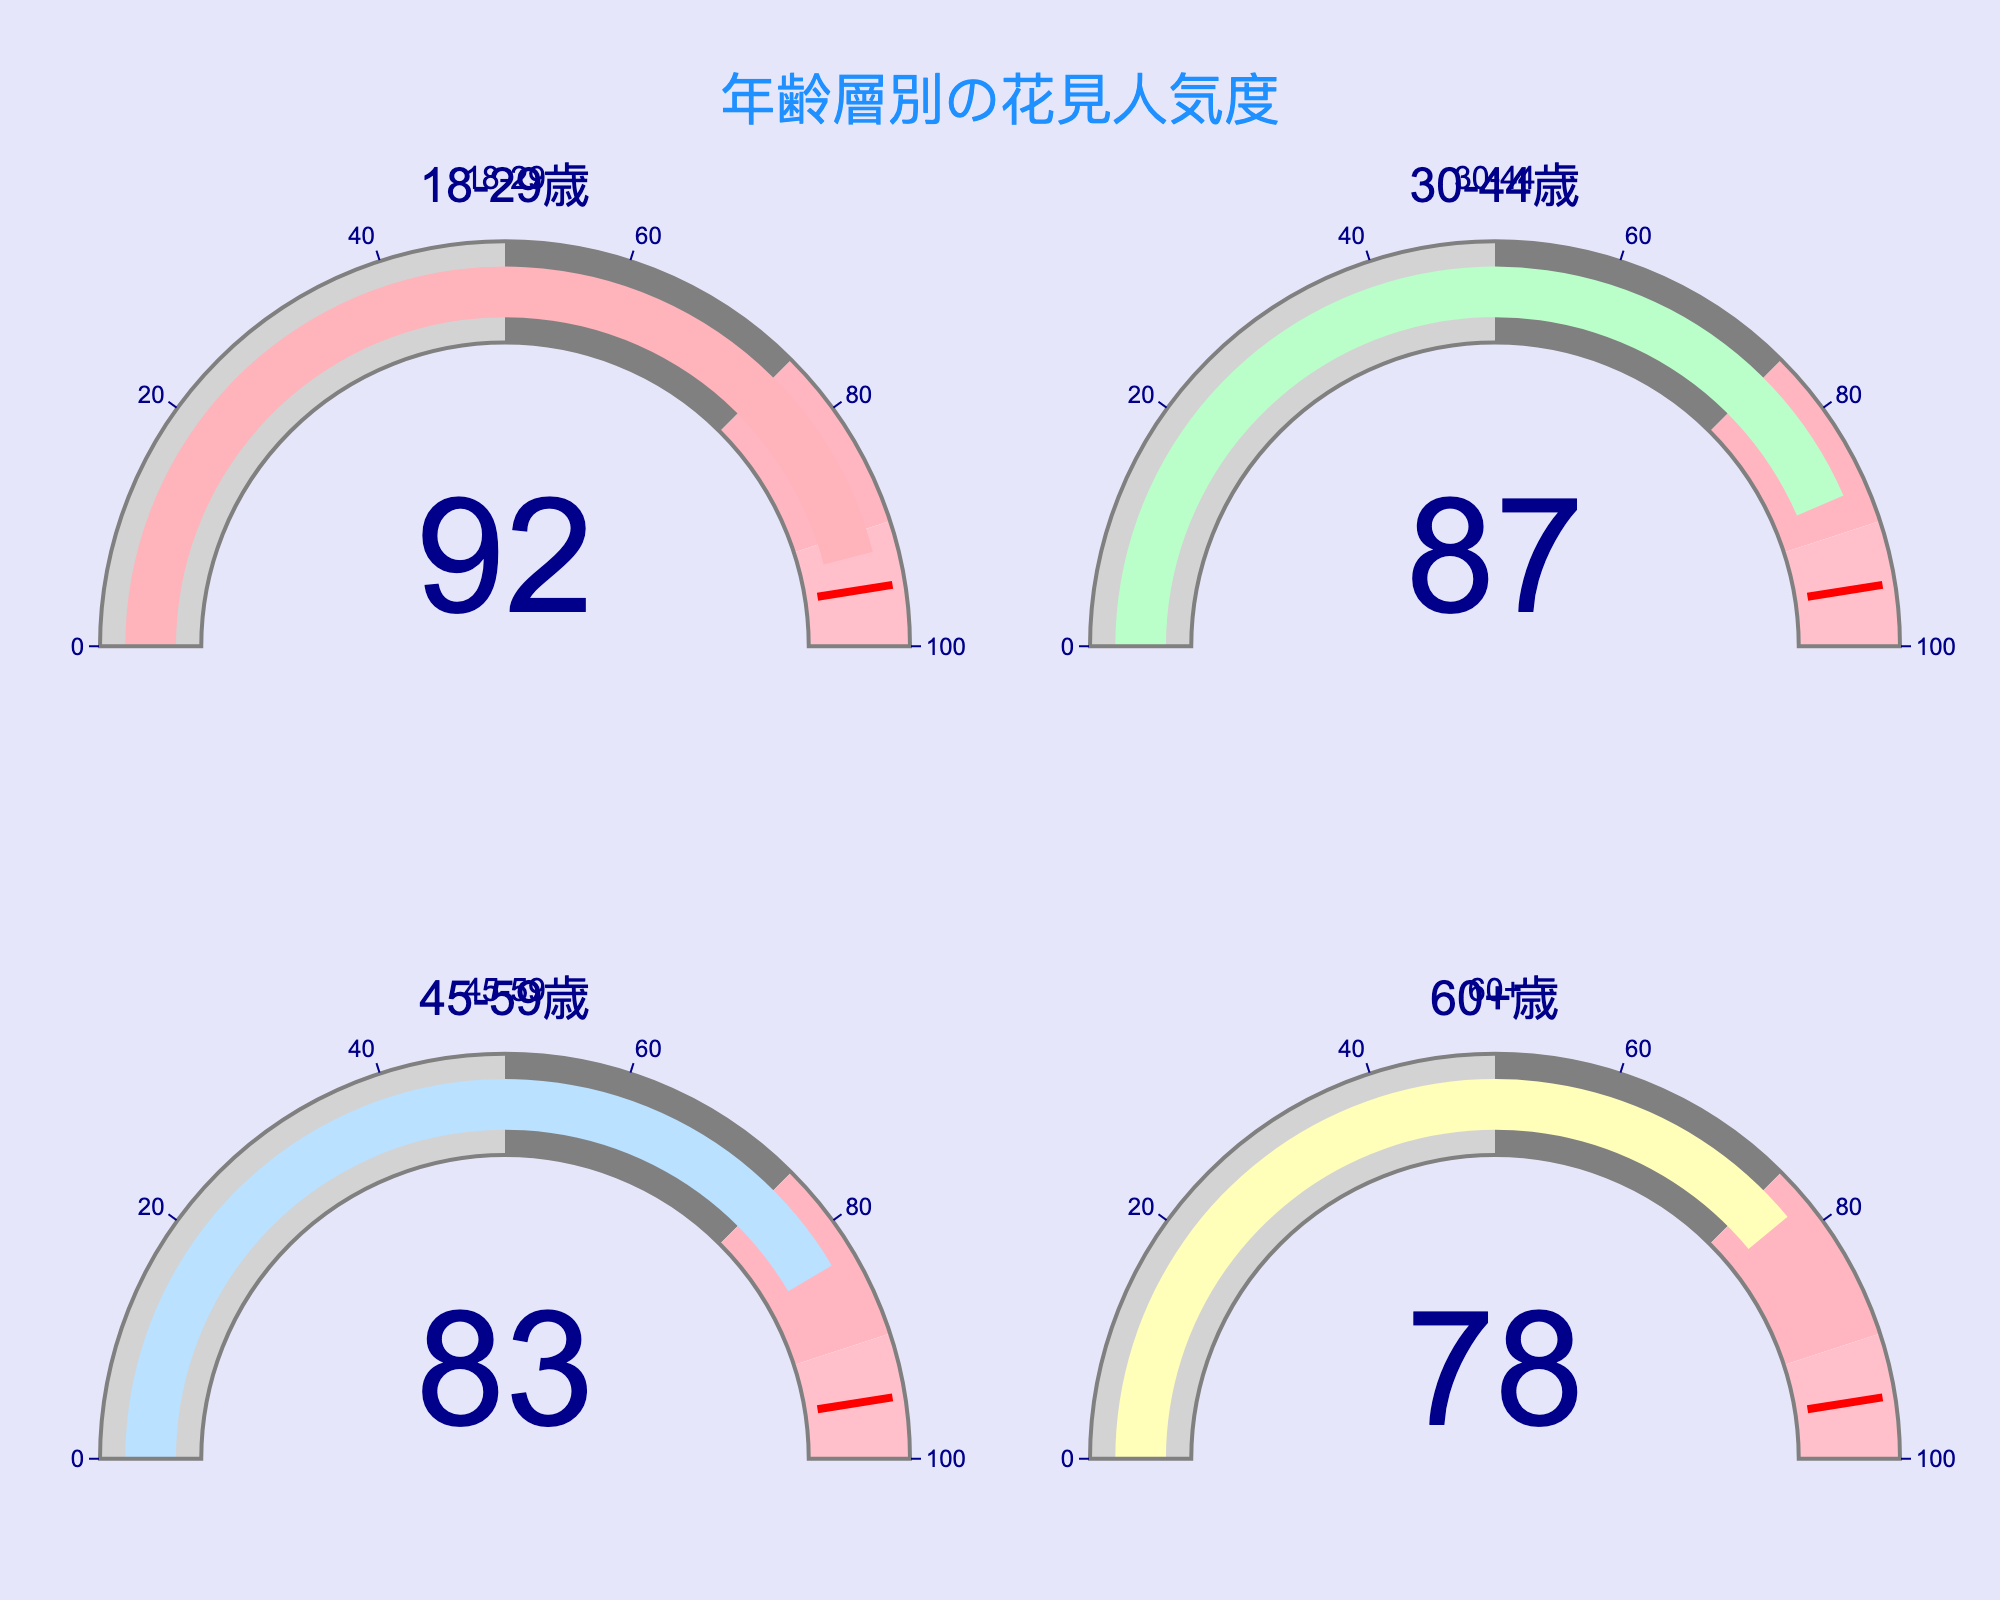What's the title of the figure? The title is displayed prominently at the top of the figure in bold font. It reads "年齢層別の花見人気度" which translates to "Hanami Popularity by Age Group".
Answer: 年齢層別の花見人気度 What is the popularity rating for the 18-29 age group? The number displayed on the gauge for the 18-29 age group is the popularity rating. It reads 92.
Answer: 92 Which age group has the lowest popularity rating? The values displayed on the gauges for each age group show that 60+ has the lowest popularity rating, which is 78.
Answer: 60+ What is the average popularity rating across all age groups? To find the average, add all the popularity ratings and divide by the number of groups: (92 + 87 + 83 + 78) / 4 = 340 / 4 = 85.
Answer: 85 What is the difference in popularity rating between the 18-29 and 60+ age groups? Subtract the popularity rating of the 60+ group from the 18-29 group: 92 - 78 = 14.
Answer: 14 How many age groups are represented in the figure? The figure is divided into four segments, each representing a different age group as shown in the titles on each gauge subplot.
Answer: 4 What is the range of the gauge indicators? Each gauge has an axis range from 0 to 100, indicated by the markings on the gauge.
Answer: 0 to 100 Which two age groups have the closest popularity ratings, and what is their difference? The groups 45-59 and 60+ have the closest ratings of 83 and 78 respectively. The difference is 83 - 78 = 5.
Answer: 45-59, 60+, 5 Which age group shows a popularity rating in the "gray" 50-75 range? None of the age groups fall within the 50-75 range indicated by the gray color on the gauge. They all are above 75.
Answer: None 